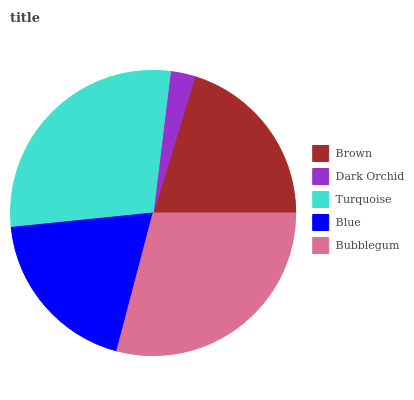Is Dark Orchid the minimum?
Answer yes or no. Yes. Is Bubblegum the maximum?
Answer yes or no. Yes. Is Turquoise the minimum?
Answer yes or no. No. Is Turquoise the maximum?
Answer yes or no. No. Is Turquoise greater than Dark Orchid?
Answer yes or no. Yes. Is Dark Orchid less than Turquoise?
Answer yes or no. Yes. Is Dark Orchid greater than Turquoise?
Answer yes or no. No. Is Turquoise less than Dark Orchid?
Answer yes or no. No. Is Brown the high median?
Answer yes or no. Yes. Is Brown the low median?
Answer yes or no. Yes. Is Turquoise the high median?
Answer yes or no. No. Is Turquoise the low median?
Answer yes or no. No. 